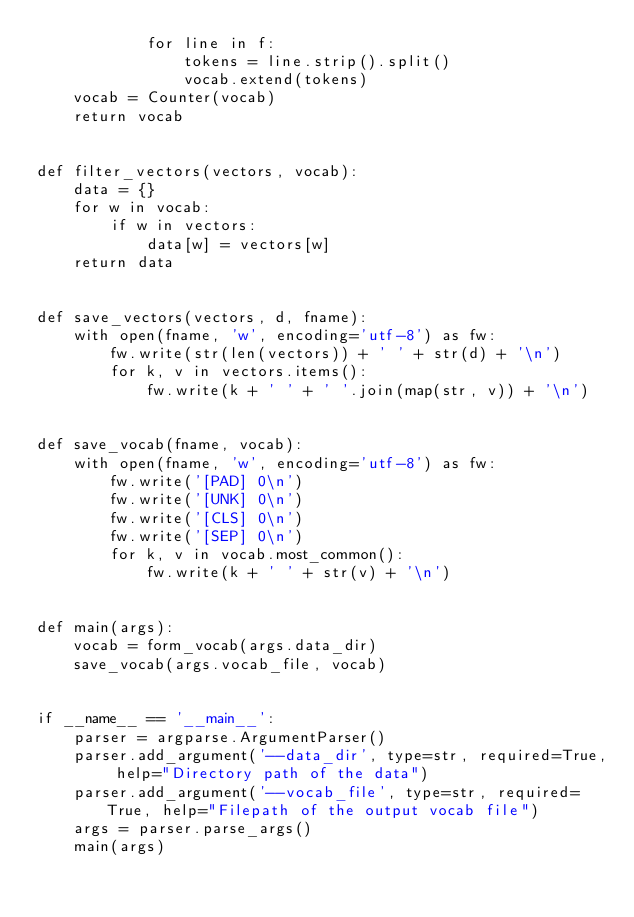Convert code to text. <code><loc_0><loc_0><loc_500><loc_500><_Python_>            for line in f:
                tokens = line.strip().split()
                vocab.extend(tokens)
    vocab = Counter(vocab)
    return vocab


def filter_vectors(vectors, vocab):
    data = {}
    for w in vocab:
        if w in vectors:
            data[w] = vectors[w]
    return data


def save_vectors(vectors, d, fname):
    with open(fname, 'w', encoding='utf-8') as fw:
        fw.write(str(len(vectors)) + ' ' + str(d) + '\n')
        for k, v in vectors.items():
            fw.write(k + ' ' + ' '.join(map(str, v)) + '\n')


def save_vocab(fname, vocab):
    with open(fname, 'w', encoding='utf-8') as fw:
        fw.write('[PAD] 0\n')
        fw.write('[UNK] 0\n')
        fw.write('[CLS] 0\n')
        fw.write('[SEP] 0\n')
        for k, v in vocab.most_common():
            fw.write(k + ' ' + str(v) + '\n')


def main(args):
    vocab = form_vocab(args.data_dir)
    save_vocab(args.vocab_file, vocab)


if __name__ == '__main__':
    parser = argparse.ArgumentParser()
    parser.add_argument('--data_dir', type=str, required=True, help="Directory path of the data")
    parser.add_argument('--vocab_file', type=str, required=True, help="Filepath of the output vocab file")
    args = parser.parse_args()
    main(args)
</code> 